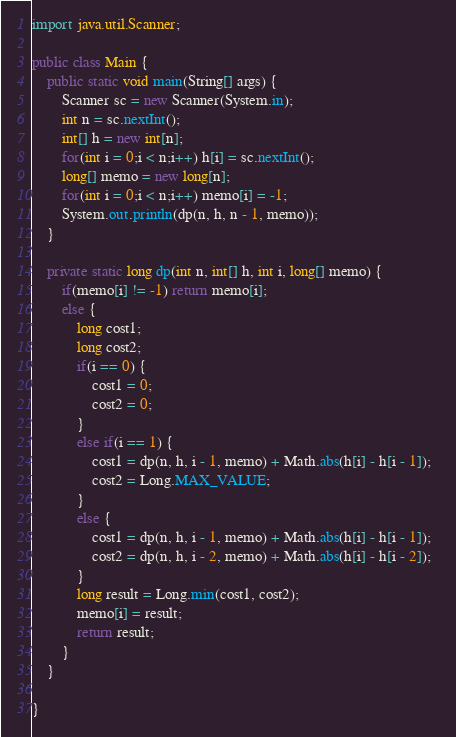Convert code to text. <code><loc_0><loc_0><loc_500><loc_500><_Java_>import java.util.Scanner;

public class Main {
    public static void main(String[] args) {
        Scanner sc = new Scanner(System.in);
        int n = sc.nextInt();
        int[] h = new int[n];
        for(int i = 0;i < n;i++) h[i] = sc.nextInt();
        long[] memo = new long[n];
        for(int i = 0;i < n;i++) memo[i] = -1;
        System.out.println(dp(n, h, n - 1, memo));
    }

    private static long dp(int n, int[] h, int i, long[] memo) {
        if(memo[i] != -1) return memo[i];
        else {
            long cost1;
            long cost2;
            if(i == 0) {
                cost1 = 0;
                cost2 = 0;
            }
            else if(i == 1) {
                cost1 = dp(n, h, i - 1, memo) + Math.abs(h[i] - h[i - 1]);
                cost2 = Long.MAX_VALUE;
            }
            else {
                cost1 = dp(n, h, i - 1, memo) + Math.abs(h[i] - h[i - 1]);
                cost2 = dp(n, h, i - 2, memo) + Math.abs(h[i] - h[i - 2]);  
            }
            long result = Long.min(cost1, cost2);
            memo[i] = result;
            return result;
        }
    }

}
</code> 